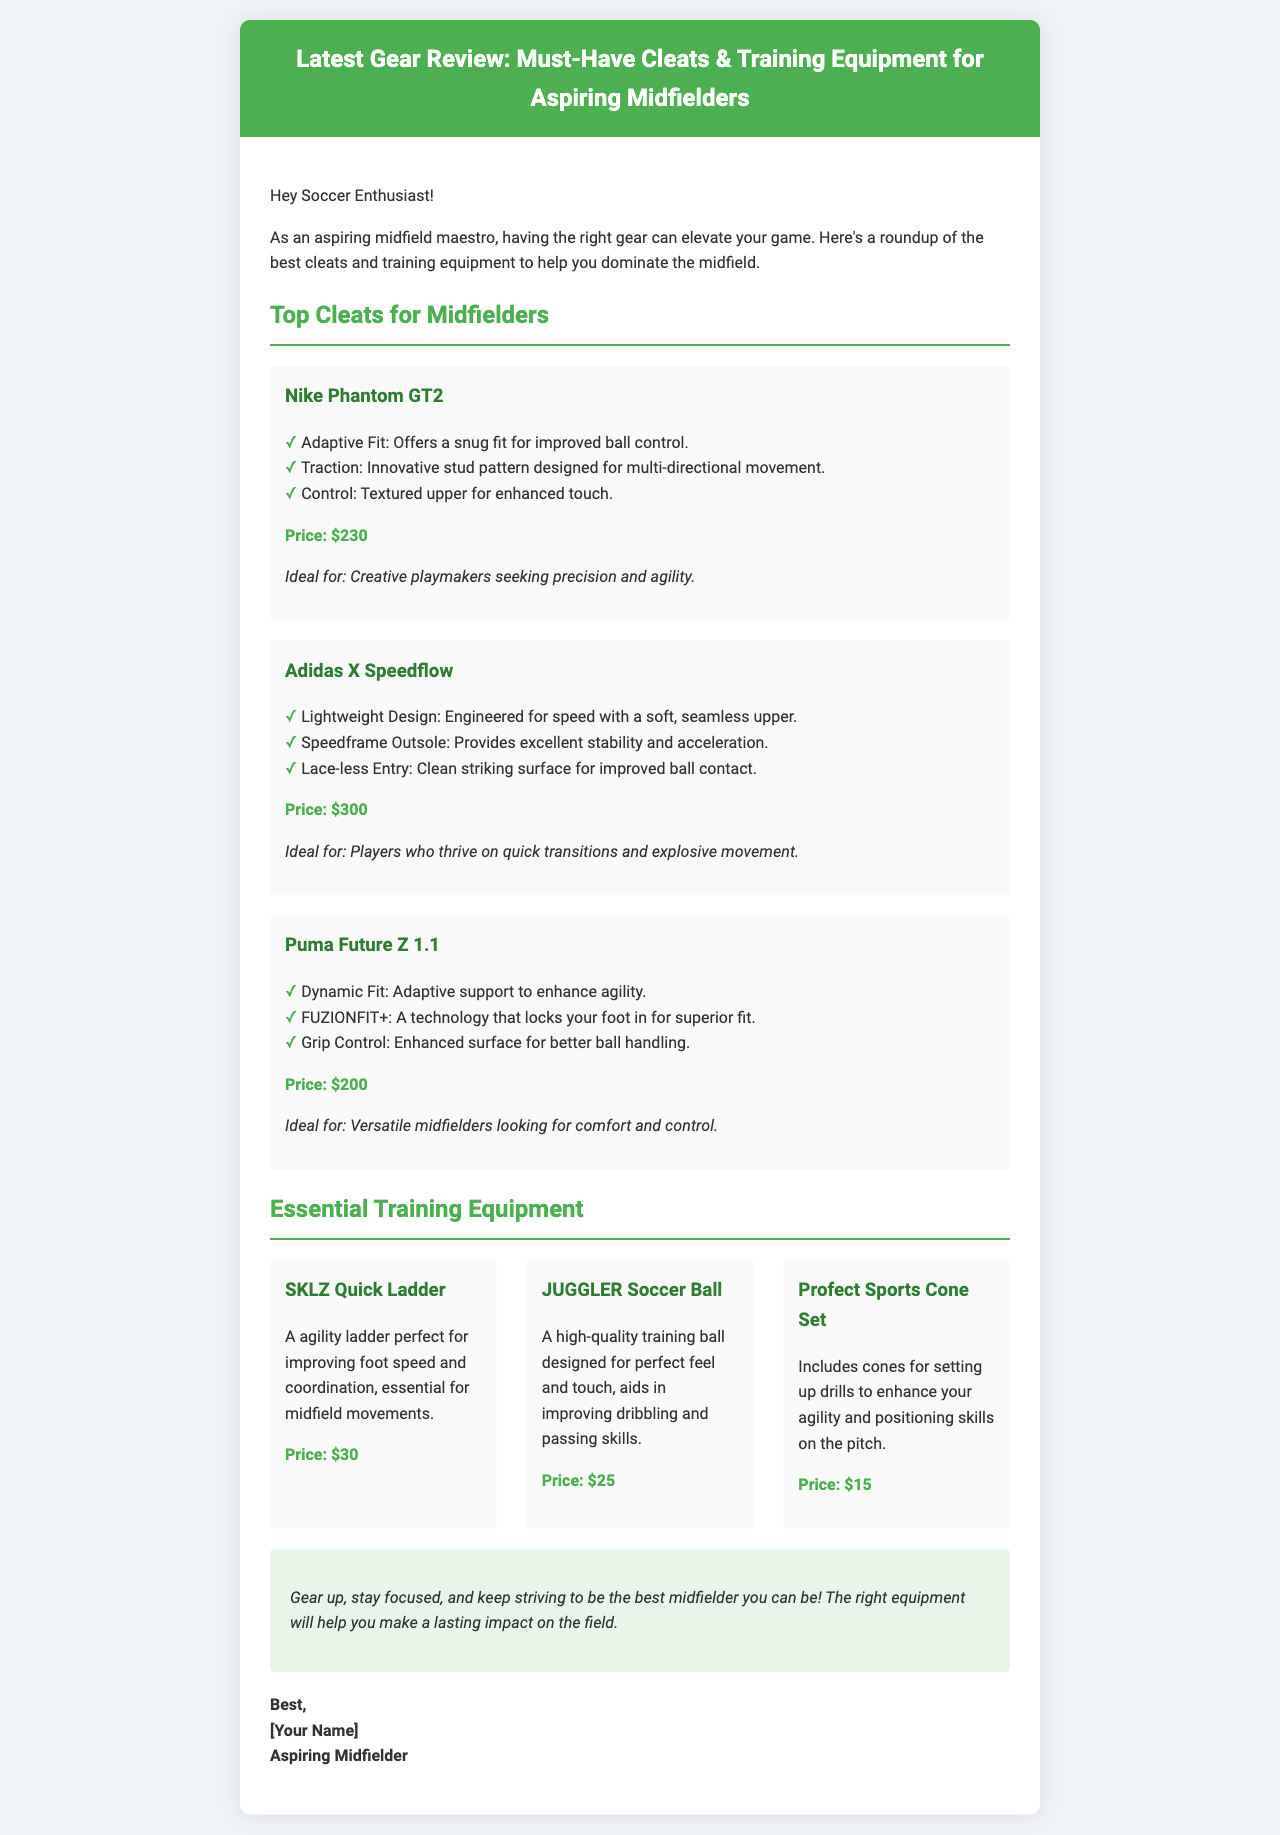What is the title of the email? The title of the email is given in the header section, highlighting the content about gear for midfielders.
Answer: Latest Gear Review: Must-Have Cleats & Training Equipment for Aspiring Midfielders How many cleats are reviewed? The number of reviewed cleats can be found in the section for Top Cleats for Midfielders, indicating the total items listed.
Answer: Three What is the price of the Nike Phantom GT2? The price can be located under the description of the Nike Phantom GT2 cleat, detailing its cost for buyers.
Answer: $230 What equipment is priced at $30? The item priced at $30 is mentioned in the Essential Training Equipment section, listing its features and purpose.
Answer: SKLZ Quick Ladder Which cleat is ideal for creative playmakers? The ideal cleat for creative playmakers is specified in the product description, indicating which one suits this category.
Answer: Nike Phantom GT2 What is included in the Profect Sports Cone Set? The document describes the Profect Sports Cone Set, allowing understanding of what it contains for training purposes.
Answer: Cones What does the closing paragraph encourage? The closing paragraph highlights the main message or encouragement directed toward aspiring midfielders, uplifting their dedication.
Answer: Gear up, stay focused, and keep striving to be the best midfielder you can be! 